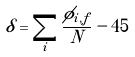Convert formula to latex. <formula><loc_0><loc_0><loc_500><loc_500>\delta = \sum _ { i } \frac { \phi _ { i , f } } { N } - 4 5</formula> 